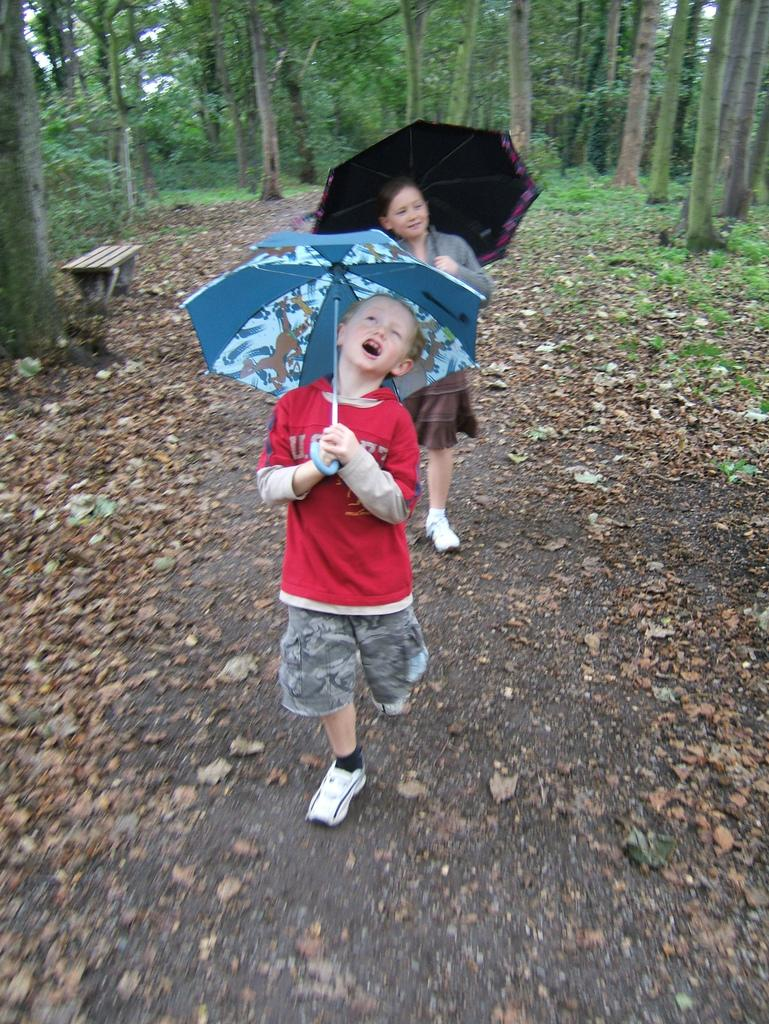What are the people in the image using to protect themselves from the weather? The people in the image are holding umbrellas. What type of surface is visible in the image? There is ground visible in the image. What type of vegetation is present on the ground? Grass and dried leaves are present on the ground. What type of plants can be seen in the image? There are plants and trees in the image. What type of seating is available in the image? There is a bench in the image. Where is the coat hanging on the tree in the image? There is no coat present in the image. What type of crib is visible in the image? There is no crib present in the image. 